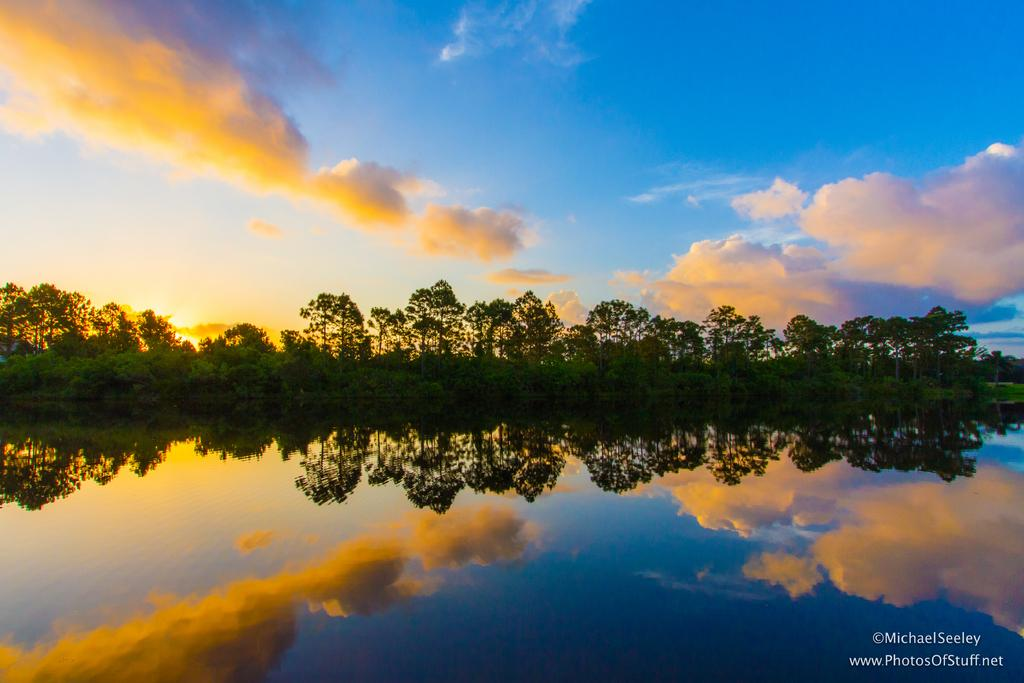What type of vegetation can be seen in the image? There are trees in the image. What is located at the bottom of the image? There is water at the bottom of the image. What can be seen written or printed in the image? There is text visible in the image. What is visible at the top of the image? There is sunlight at the top of the image. What is present in the sky in the image? There are clouds in the sky. What type of orange can be seen growing on the trees in the image? There are no oranges present in the image; the trees are not specified as fruit-bearing trees. What is the rail used for in the image? There is no rail present in the image. How many stones can be seen in the image? There are no stones visible in the image. 